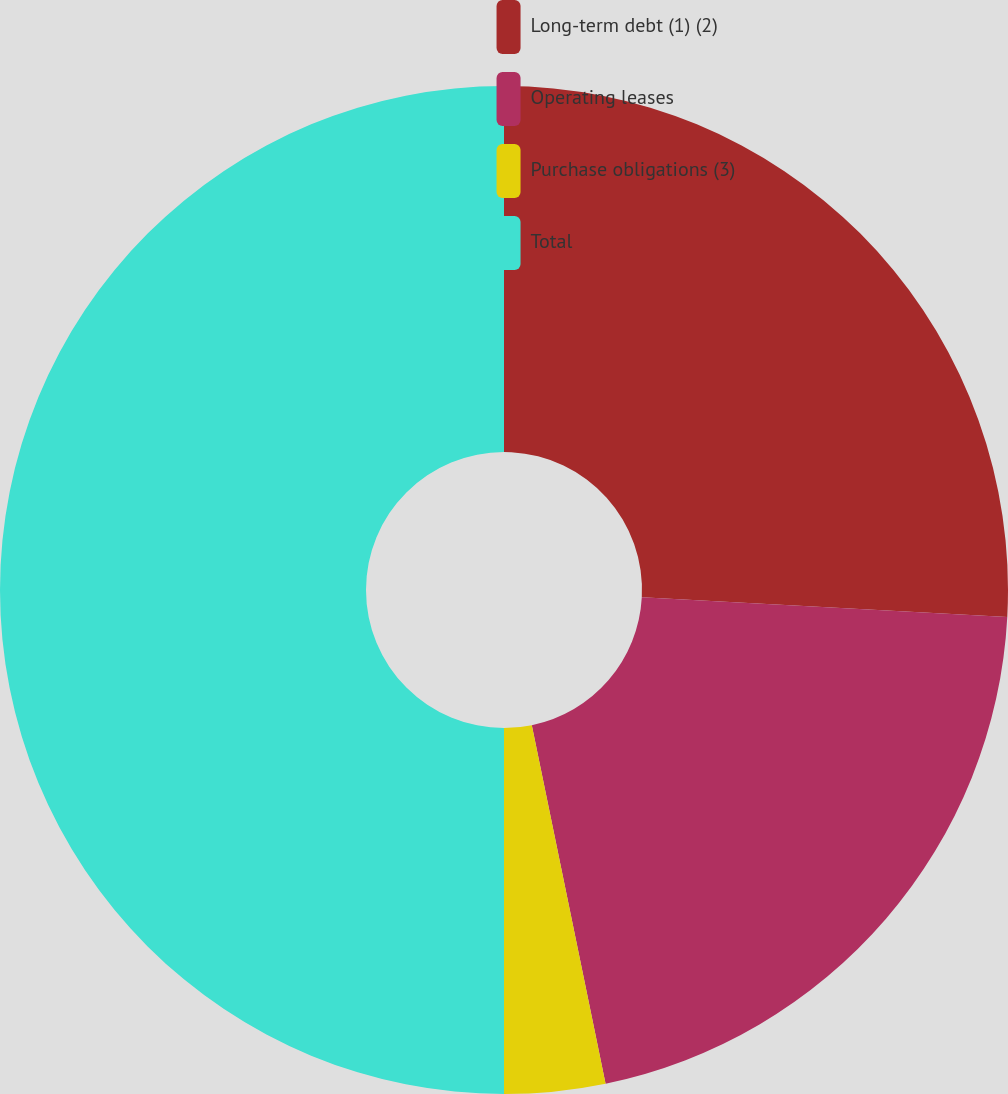Convert chart. <chart><loc_0><loc_0><loc_500><loc_500><pie_chart><fcel>Long-term debt (1) (2)<fcel>Operating leases<fcel>Purchase obligations (3)<fcel>Total<nl><fcel>25.85%<fcel>20.92%<fcel>3.23%<fcel>50.0%<nl></chart> 